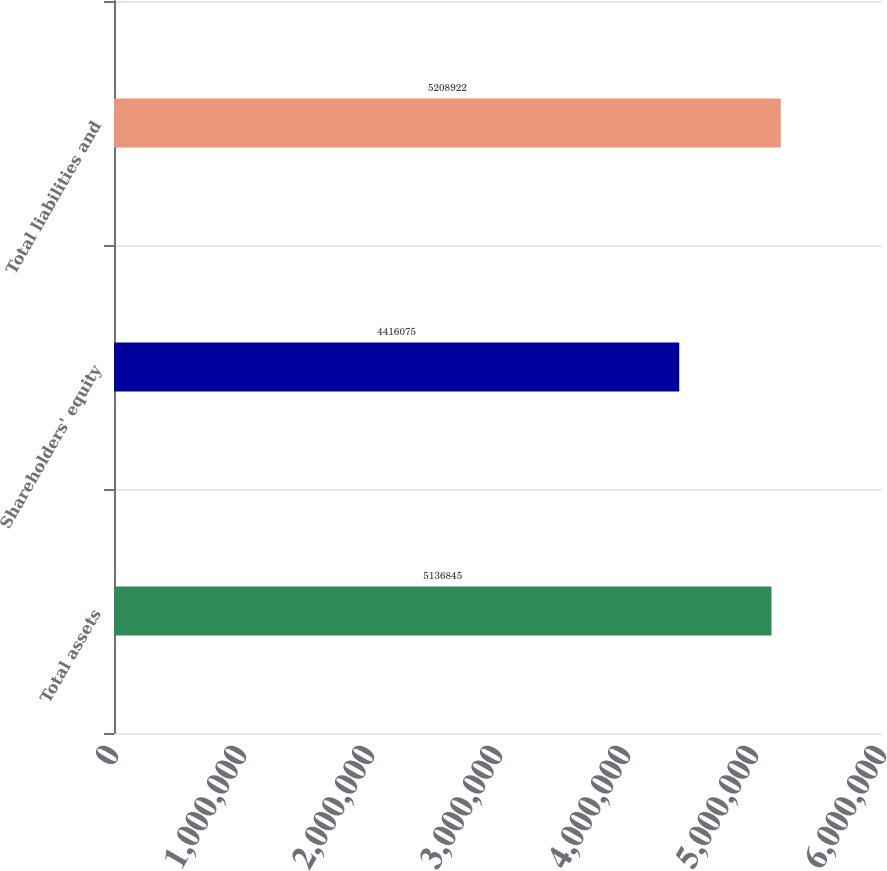Convert chart to OTSL. <chart><loc_0><loc_0><loc_500><loc_500><bar_chart><fcel>Total assets<fcel>Shareholders' equity<fcel>Total liabilities and<nl><fcel>5.13684e+06<fcel>4.41608e+06<fcel>5.20892e+06<nl></chart> 